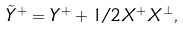Convert formula to latex. <formula><loc_0><loc_0><loc_500><loc_500>\tilde { Y } ^ { + } = Y ^ { + } + 1 / 2 X ^ { + } X ^ { \perp } ,</formula> 